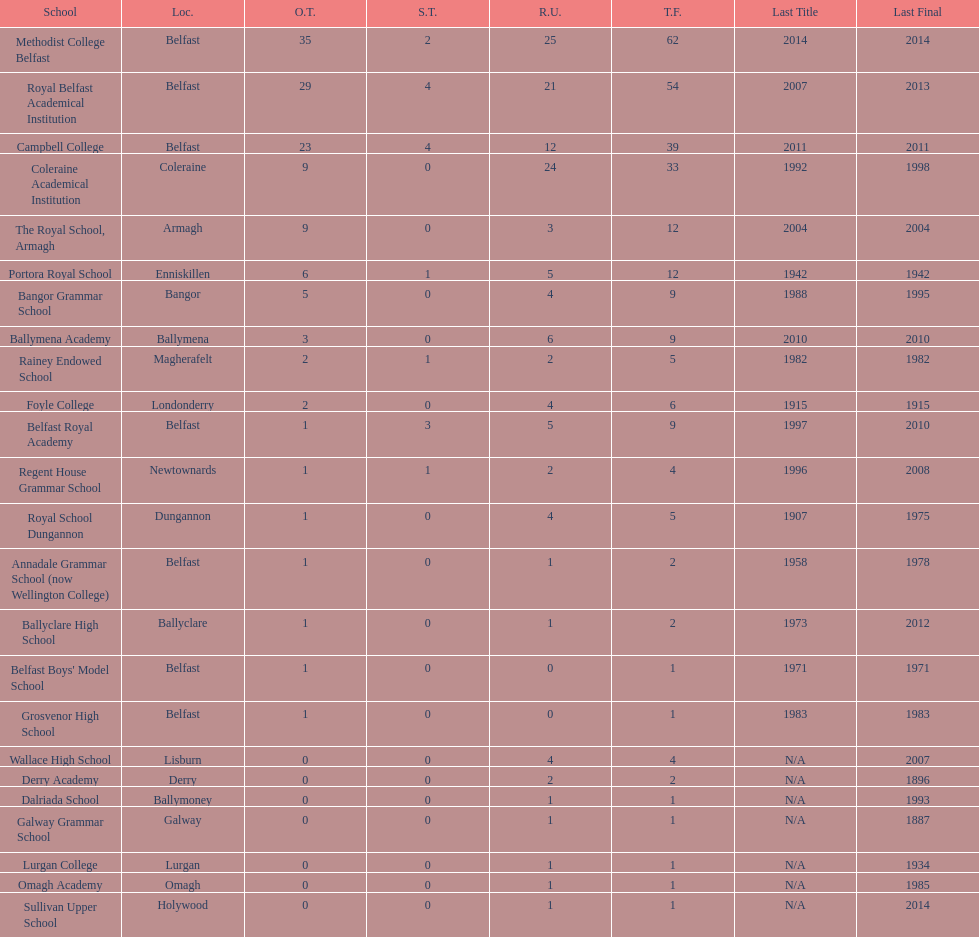What is the difference in runners-up from coleraine academical institution and royal school dungannon? 20. 